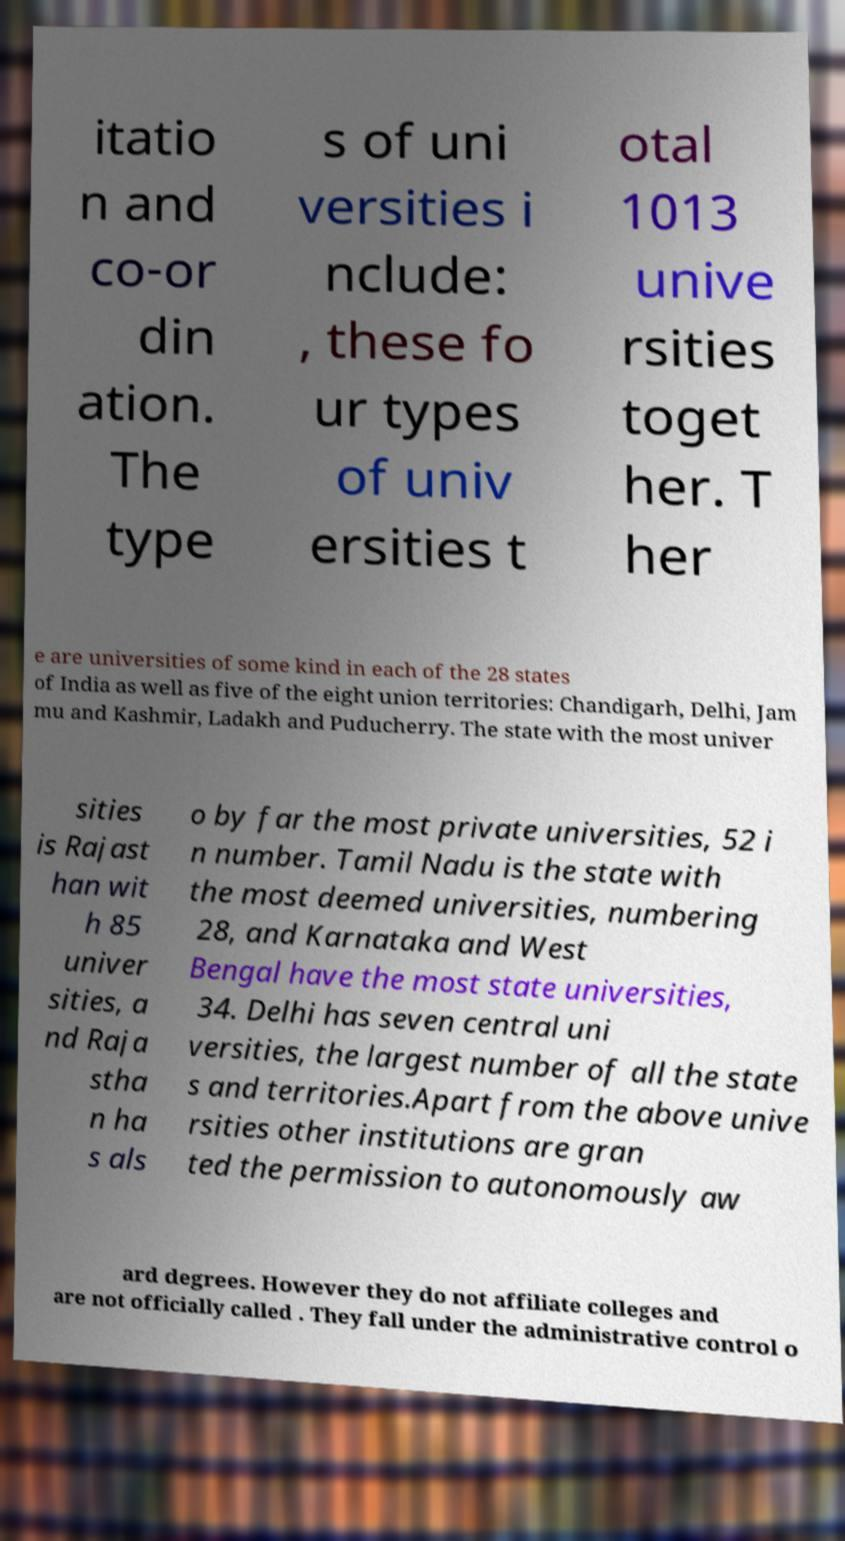Could you assist in decoding the text presented in this image and type it out clearly? itatio n and co-or din ation. The type s of uni versities i nclude: , these fo ur types of univ ersities t otal 1013 unive rsities toget her. T her e are universities of some kind in each of the 28 states of India as well as five of the eight union territories: Chandigarh, Delhi, Jam mu and Kashmir, Ladakh and Puducherry. The state with the most univer sities is Rajast han wit h 85 univer sities, a nd Raja stha n ha s als o by far the most private universities, 52 i n number. Tamil Nadu is the state with the most deemed universities, numbering 28, and Karnataka and West Bengal have the most state universities, 34. Delhi has seven central uni versities, the largest number of all the state s and territories.Apart from the above unive rsities other institutions are gran ted the permission to autonomously aw ard degrees. However they do not affiliate colleges and are not officially called . They fall under the administrative control o 